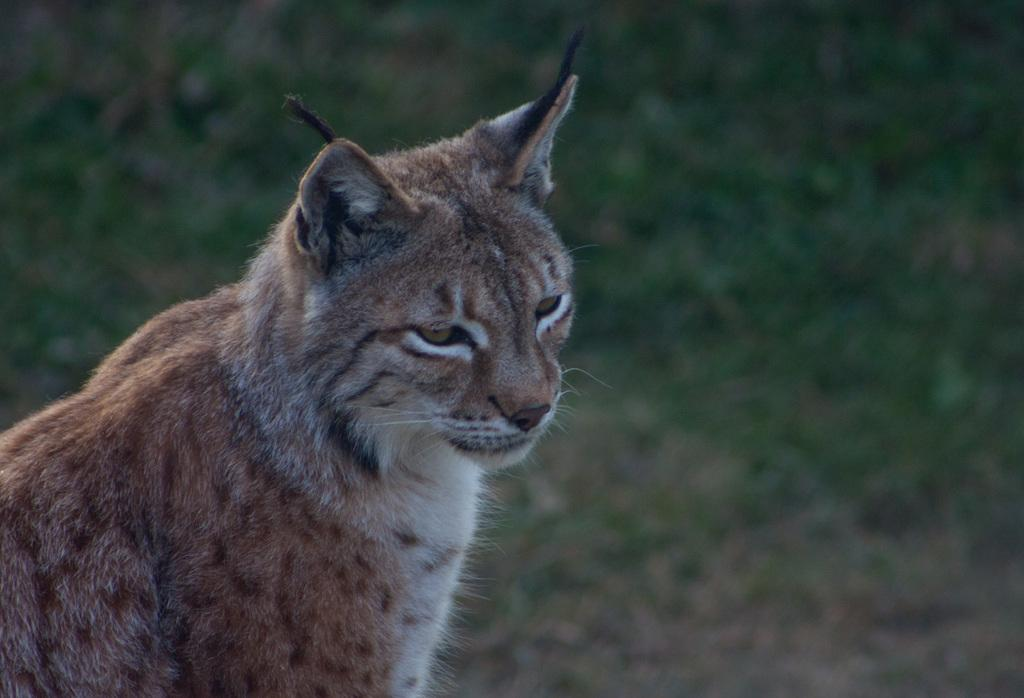What type of animal is in the picture? There is a cat in the picture. What is the background of the picture? There is grass at the bottom of the picture. What type of toy does the cat's uncle play with in the picture? There is no toy or uncle present in the picture; it only features a cat and grass. 